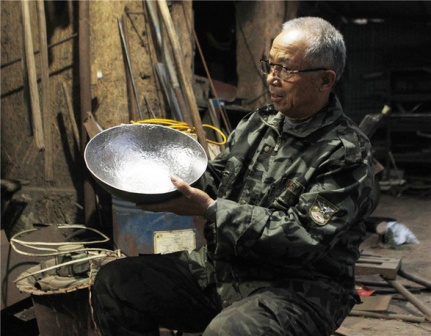What does the man find so captivating about the metal bowl? The man seems to be engrossed in the intricate details of the metal bowl, possibly reflecting on its craftsmanship or considering its use in his next project. The bowl might hold some sentimental value or be a masterpiece of his handiwork, making it an object of deep contemplation and pride for him. What stories do you think the tools in the workshop could tell? Each tool in the workshop likely has a rich history of its own. The worn handles of the hammers might speak of countless projects, each dent and scratch telling a story of perseverance and creativity. Screwdrivers with their tips worn down, saws with slightly dulled blades, and machines with layers of grime all chronicle a lifetime of dedication to craftsmanship, embodying the evolution of various creations that took shape in this space. 